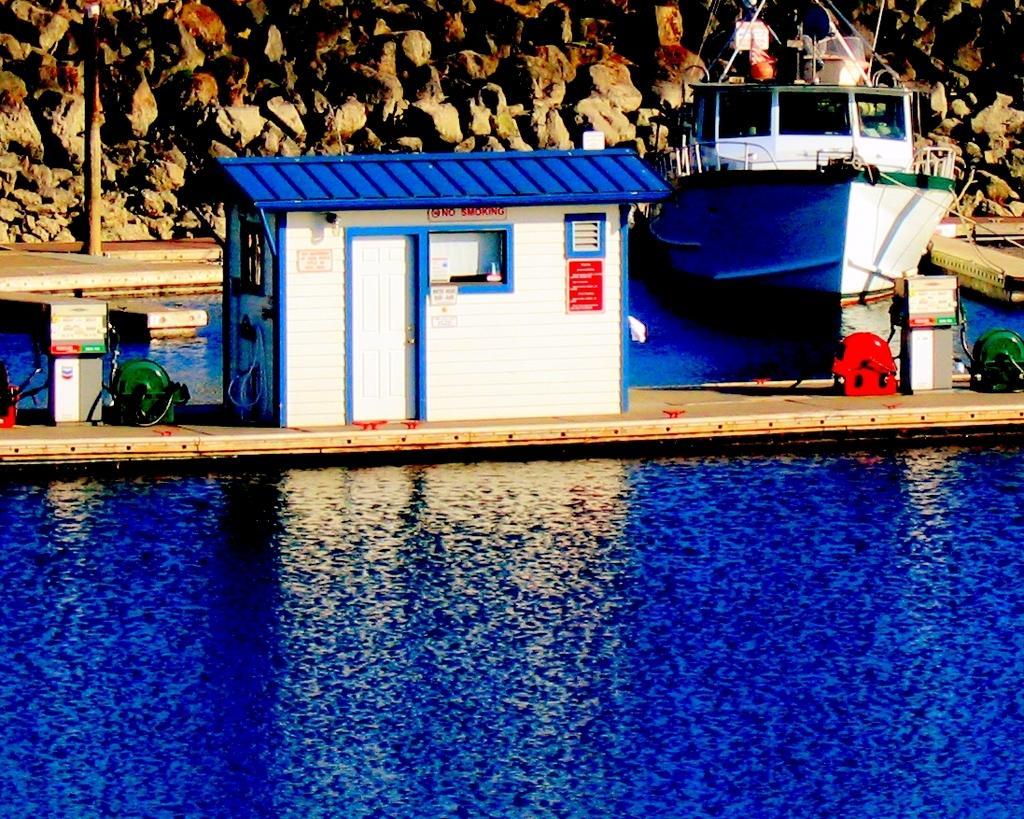In one or two sentences, can you explain what this image depicts? In this image, we can see a boat on the water. Here we can see a hut with door, wall, windows, posters. Here there are few machines, pipes, pole, footpath. Background we can see stone wall. 